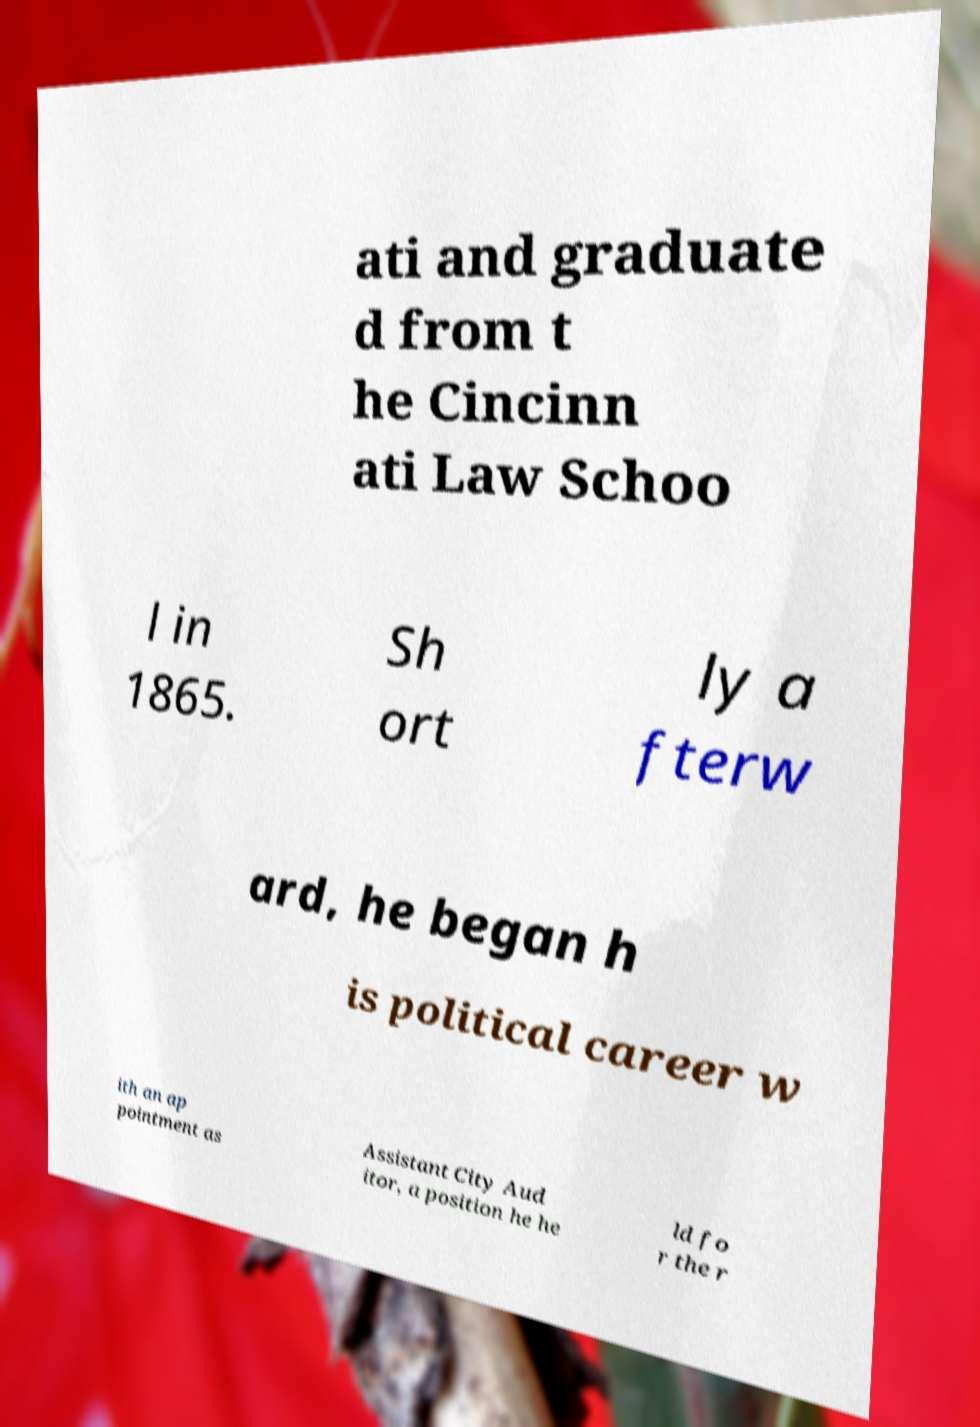There's text embedded in this image that I need extracted. Can you transcribe it verbatim? ati and graduate d from t he Cincinn ati Law Schoo l in 1865. Sh ort ly a fterw ard, he began h is political career w ith an ap pointment as Assistant City Aud itor, a position he he ld fo r the r 